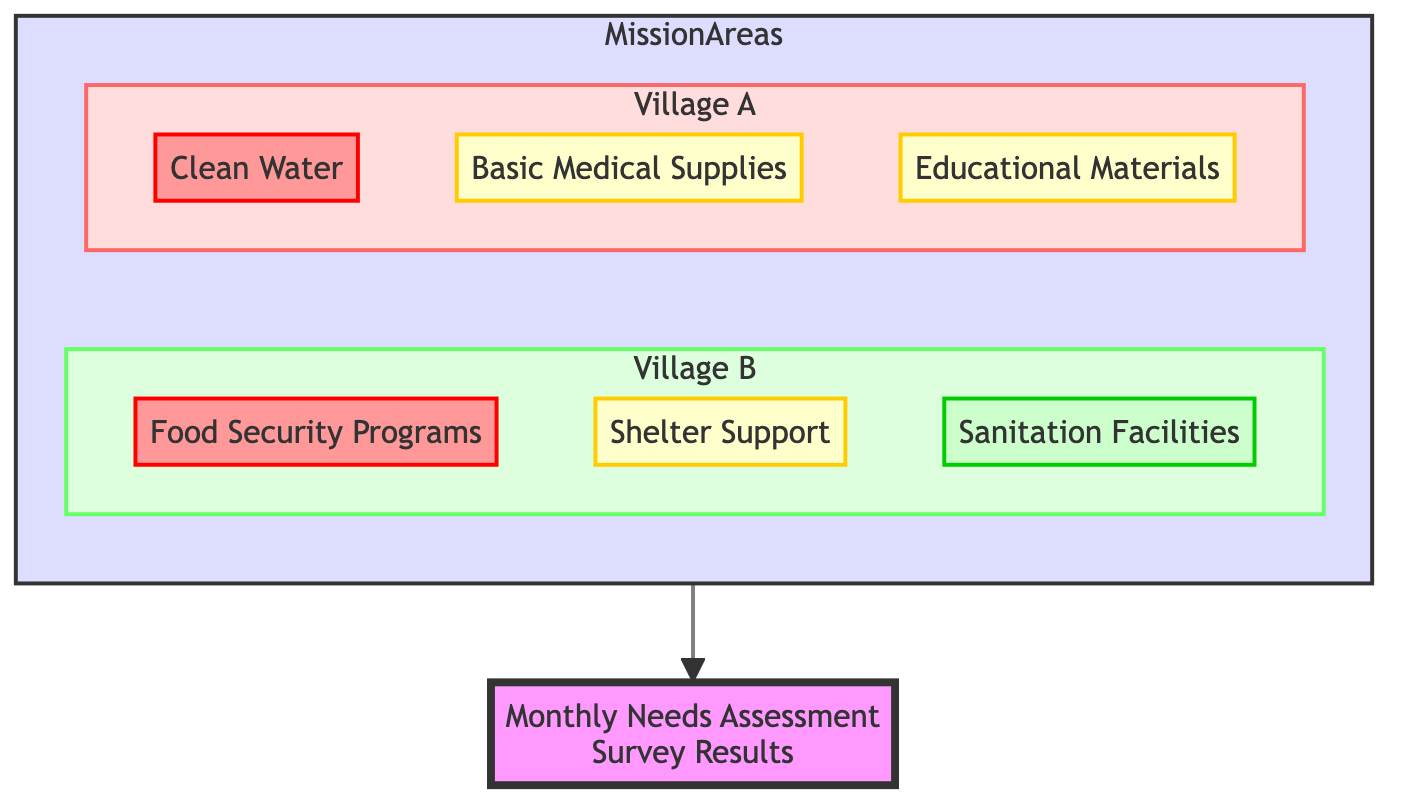What is the top priority essential in Village A? The diagram shows that the top priority essential in Village A is "Clean Water," highlighted in red with a high priority label.
Answer: Clean Water How many essentials are identified for Village B? By examining the diagram, Village B has three essentials listed: "Food Security Programs," "Shelter Support," and "Sanitation Facilities."
Answer: 3 What is the priority level of "Basic Medical Supplies"? From the diagram, "Basic Medical Supplies" is shown with a medium priority designation, which is indicated by the yellow color.
Answer: Medium Which mission area has a low priority essential? The diagram illustrates that Village B has "Sanitation Facilities" labeled with a low priority, which is shown in green.
Answer: Village B What details are associated with "Food Security Programs"? The diagram reveals that "Food Security Programs" entails providing seeds, tools, and training for sustainable farming.
Answer: Seeds, tools, and training for sustainable farming What is the relationship between "Shelter Support" and "Village B"? The flowchart indicates that "Shelter Support" is one of the prioritized essentials under Village B, suggesting that it is a need specifically highlighted for that area.
Answer: Sheltered under Village B How many high priority essentials are there in total across both villages? The diagram shows one high priority essential in Village A ("Clean Water") and one in Village B ("Food Security Programs"), making a total of two.
Answer: 2 What types of materials are included in "Sanitation Facilities"? The diagram specifies that the materials required for "Sanitation Facilities" involve the construction of latrines and waste disposal units, indicating what is needed for sanitation.
Answer: Latrines and waste disposal units Which essential has the highest priority across all mission areas? By checking the diagram, it is clear that both "Clean Water" in Village A and "Food Security Programs" in Village B are marked as high priority, making them the most critical needs.
Answer: Clean Water and Food Security Programs 